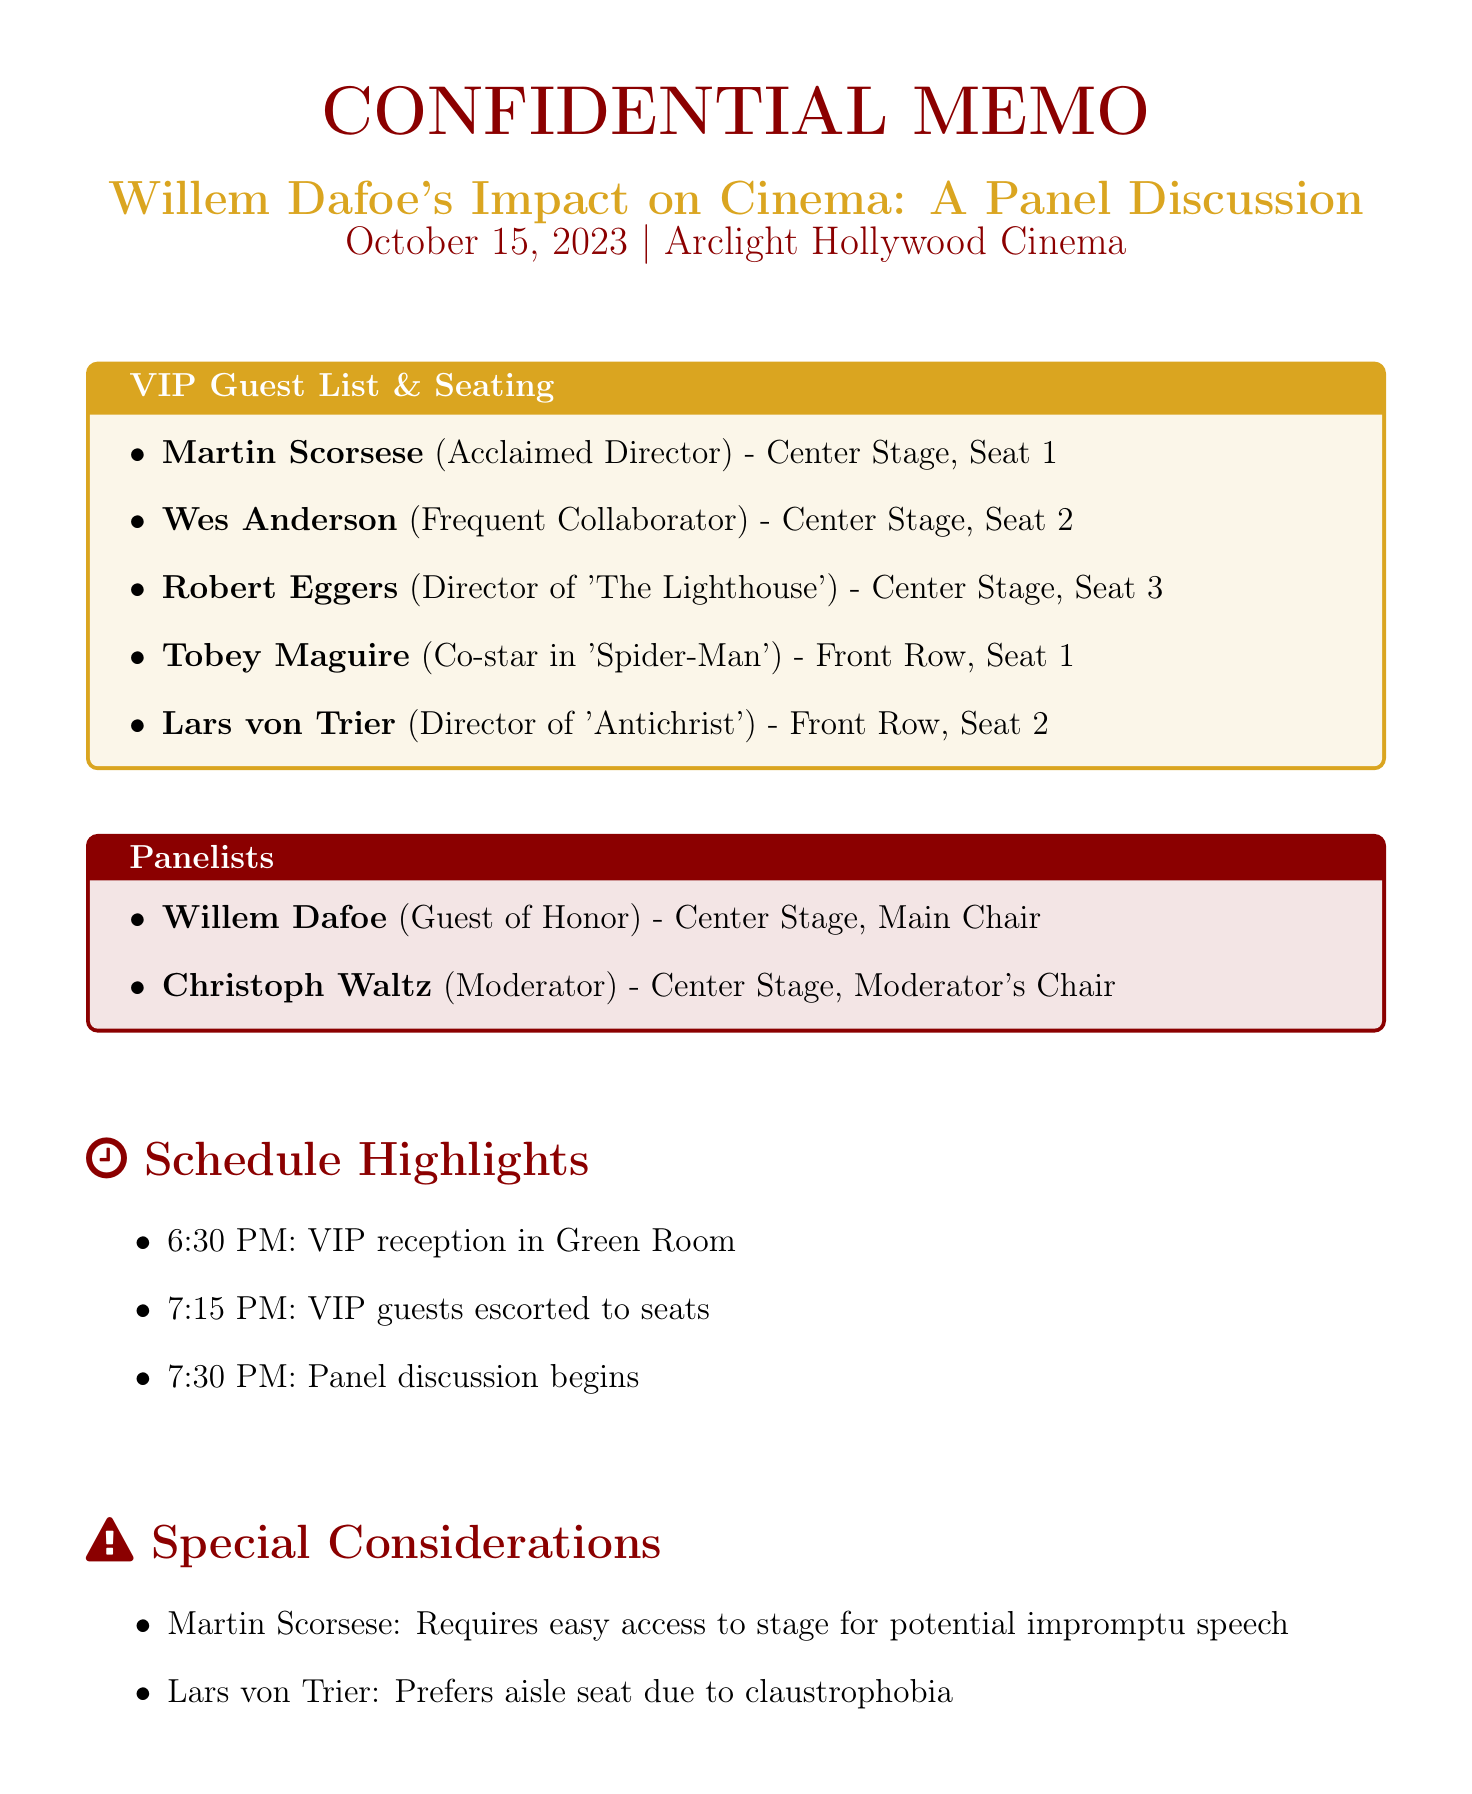What is the event name? The event name is stated at the beginning of the document under the title section.
Answer: Willem Dafoe's Impact on Cinema: A Panel Discussion When is the event scheduled? The date of the event is specified prominently in the document.
Answer: October 15, 2023 Who is seated in Center Stage, Seat 1? This question asks for a specific position listed in the VIP guest seating arrangement.
Answer: Martin Scorsese What is the role of Christoph Waltz? The role of Christoph Waltz is mentioned in the section describing the panelists.
Answer: Moderator What special requirement does Lars von Trier have? This question requires understanding the special considerations provided in the document.
Answer: Prefers aisle seat due to claustrophobia What time does the VIP reception start? The time for the VIP reception is detailed in the schedule highlights section.
Answer: 6:30 PM How many rows are designated for the VIP section? This question involves reasoning about the seating arrangements provided in the memo.
Answer: Three rows Where will the post-event gathering take place? The location for the post-event gathering is clearly listed in the document.
Answer: Chateau Marmont What security measure is mentioned for VIP guests? This question asks for specific security measures outlined in the document.
Answer: VIP wristbands for restricted area access 